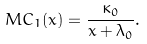Convert formula to latex. <formula><loc_0><loc_0><loc_500><loc_500>M C _ { 1 } ( x ) = \frac { \kappa _ { 0 } } { x + \lambda _ { 0 } } .</formula> 